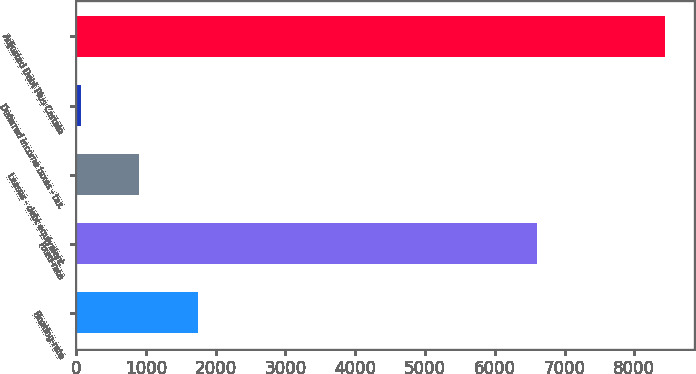Convert chart. <chart><loc_0><loc_0><loc_500><loc_500><bar_chart><fcel>Floating-rate<fcel>Fixed-rate<fcel>Leases - debt equivalent<fcel>Deferred income taxes - tax<fcel>Adjusted Debt Plus Certain<nl><fcel>1740.4<fcel>6603<fcel>903.2<fcel>66<fcel>8438<nl></chart> 